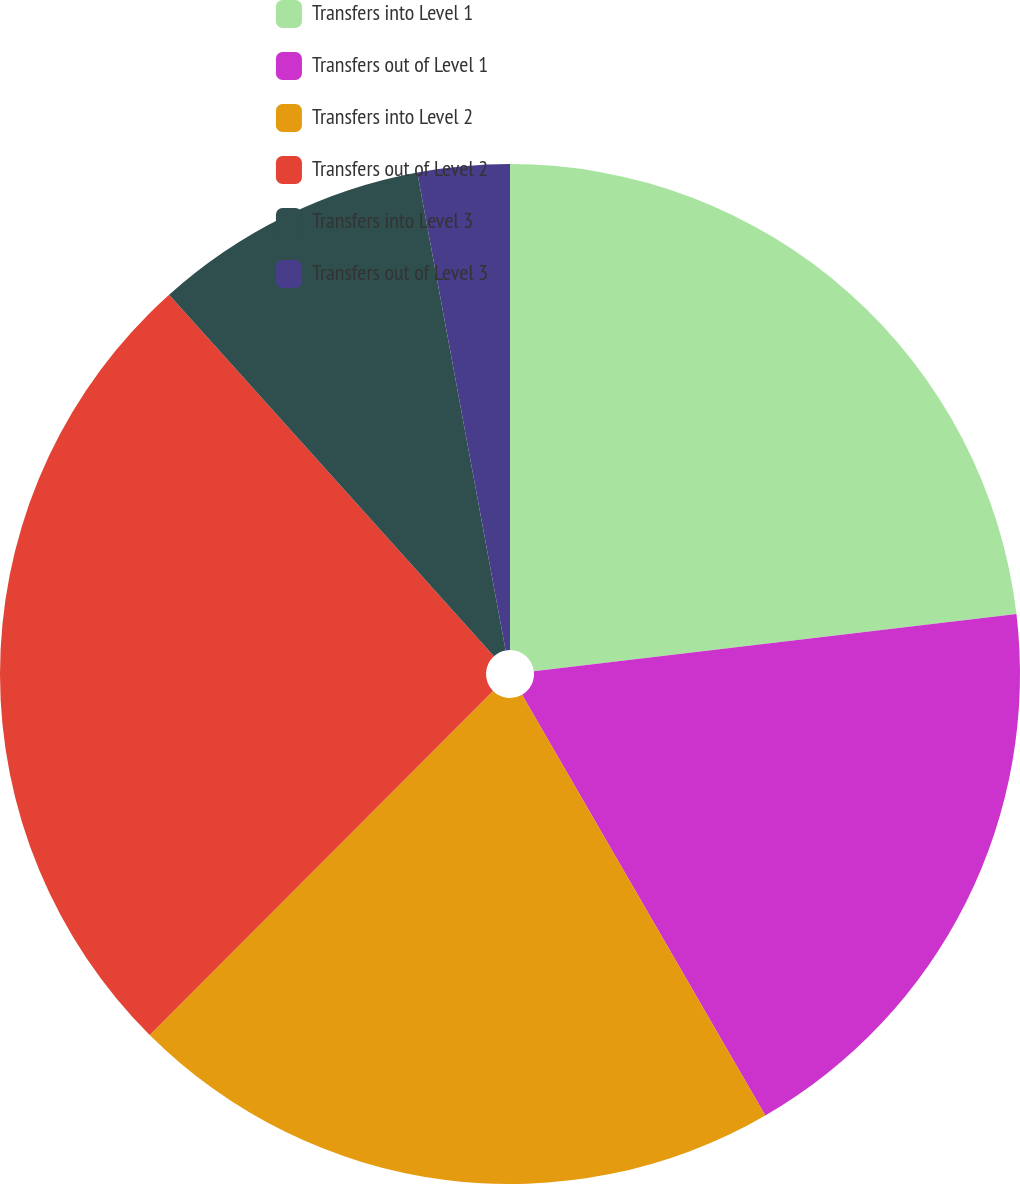<chart> <loc_0><loc_0><loc_500><loc_500><pie_chart><fcel>Transfers into Level 1<fcel>Transfers out of Level 1<fcel>Transfers into Level 2<fcel>Transfers out of Level 2<fcel>Transfers into Level 3<fcel>Transfers out of Level 3<nl><fcel>23.12%<fcel>18.53%<fcel>20.83%<fcel>25.86%<fcel>8.74%<fcel>2.91%<nl></chart> 